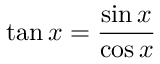Convert formula to latex. <formula><loc_0><loc_0><loc_500><loc_500>\tan x = { \frac { \sin x } { \cos x } }</formula> 